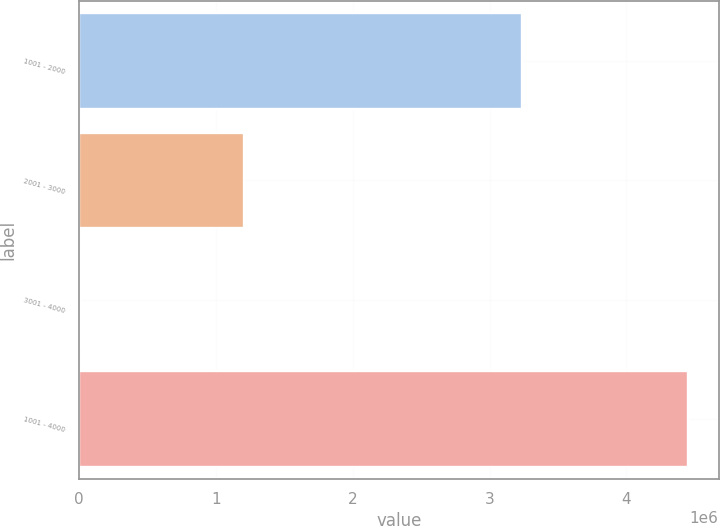Convert chart to OTSL. <chart><loc_0><loc_0><loc_500><loc_500><bar_chart><fcel>1001 - 2000<fcel>2001 - 3000<fcel>3001 - 4000<fcel>1001 - 4000<nl><fcel>3.23339e+06<fcel>1.20756e+06<fcel>10000<fcel>4.45095e+06<nl></chart> 